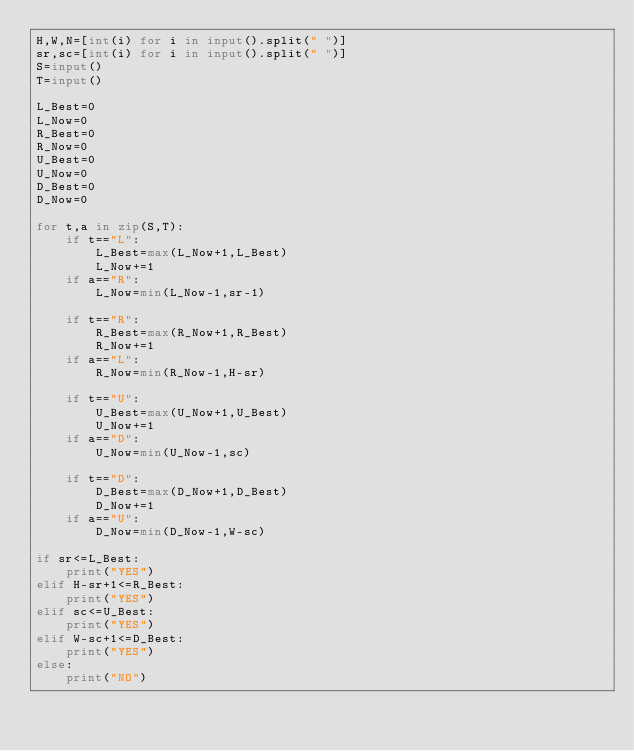Convert code to text. <code><loc_0><loc_0><loc_500><loc_500><_Python_>H,W,N=[int(i) for i in input().split(" ")]
sr,sc=[int(i) for i in input().split(" ")]
S=input()
T=input()

L_Best=0
L_Now=0
R_Best=0
R_Now=0
U_Best=0
U_Now=0
D_Best=0
D_Now=0

for t,a in zip(S,T):
    if t=="L":
        L_Best=max(L_Now+1,L_Best)
        L_Now+=1
    if a=="R":
        L_Now=min(L_Now-1,sr-1)

    if t=="R":
        R_Best=max(R_Now+1,R_Best)
        R_Now+=1
    if a=="L":
        R_Now=min(R_Now-1,H-sr)

    if t=="U":
        U_Best=max(U_Now+1,U_Best)
        U_Now+=1
    if a=="D":
        U_Now=min(U_Now-1,sc)

    if t=="D":
        D_Best=max(D_Now+1,D_Best)
        D_Now+=1
    if a=="U":
        D_Now=min(D_Now-1,W-sc)

if sr<=L_Best:
    print("YES")
elif H-sr+1<=R_Best:
    print("YES")
elif sc<=U_Best:
    print("YES")
elif W-sc+1<=D_Best:
    print("YES")
else:
    print("NO")
</code> 